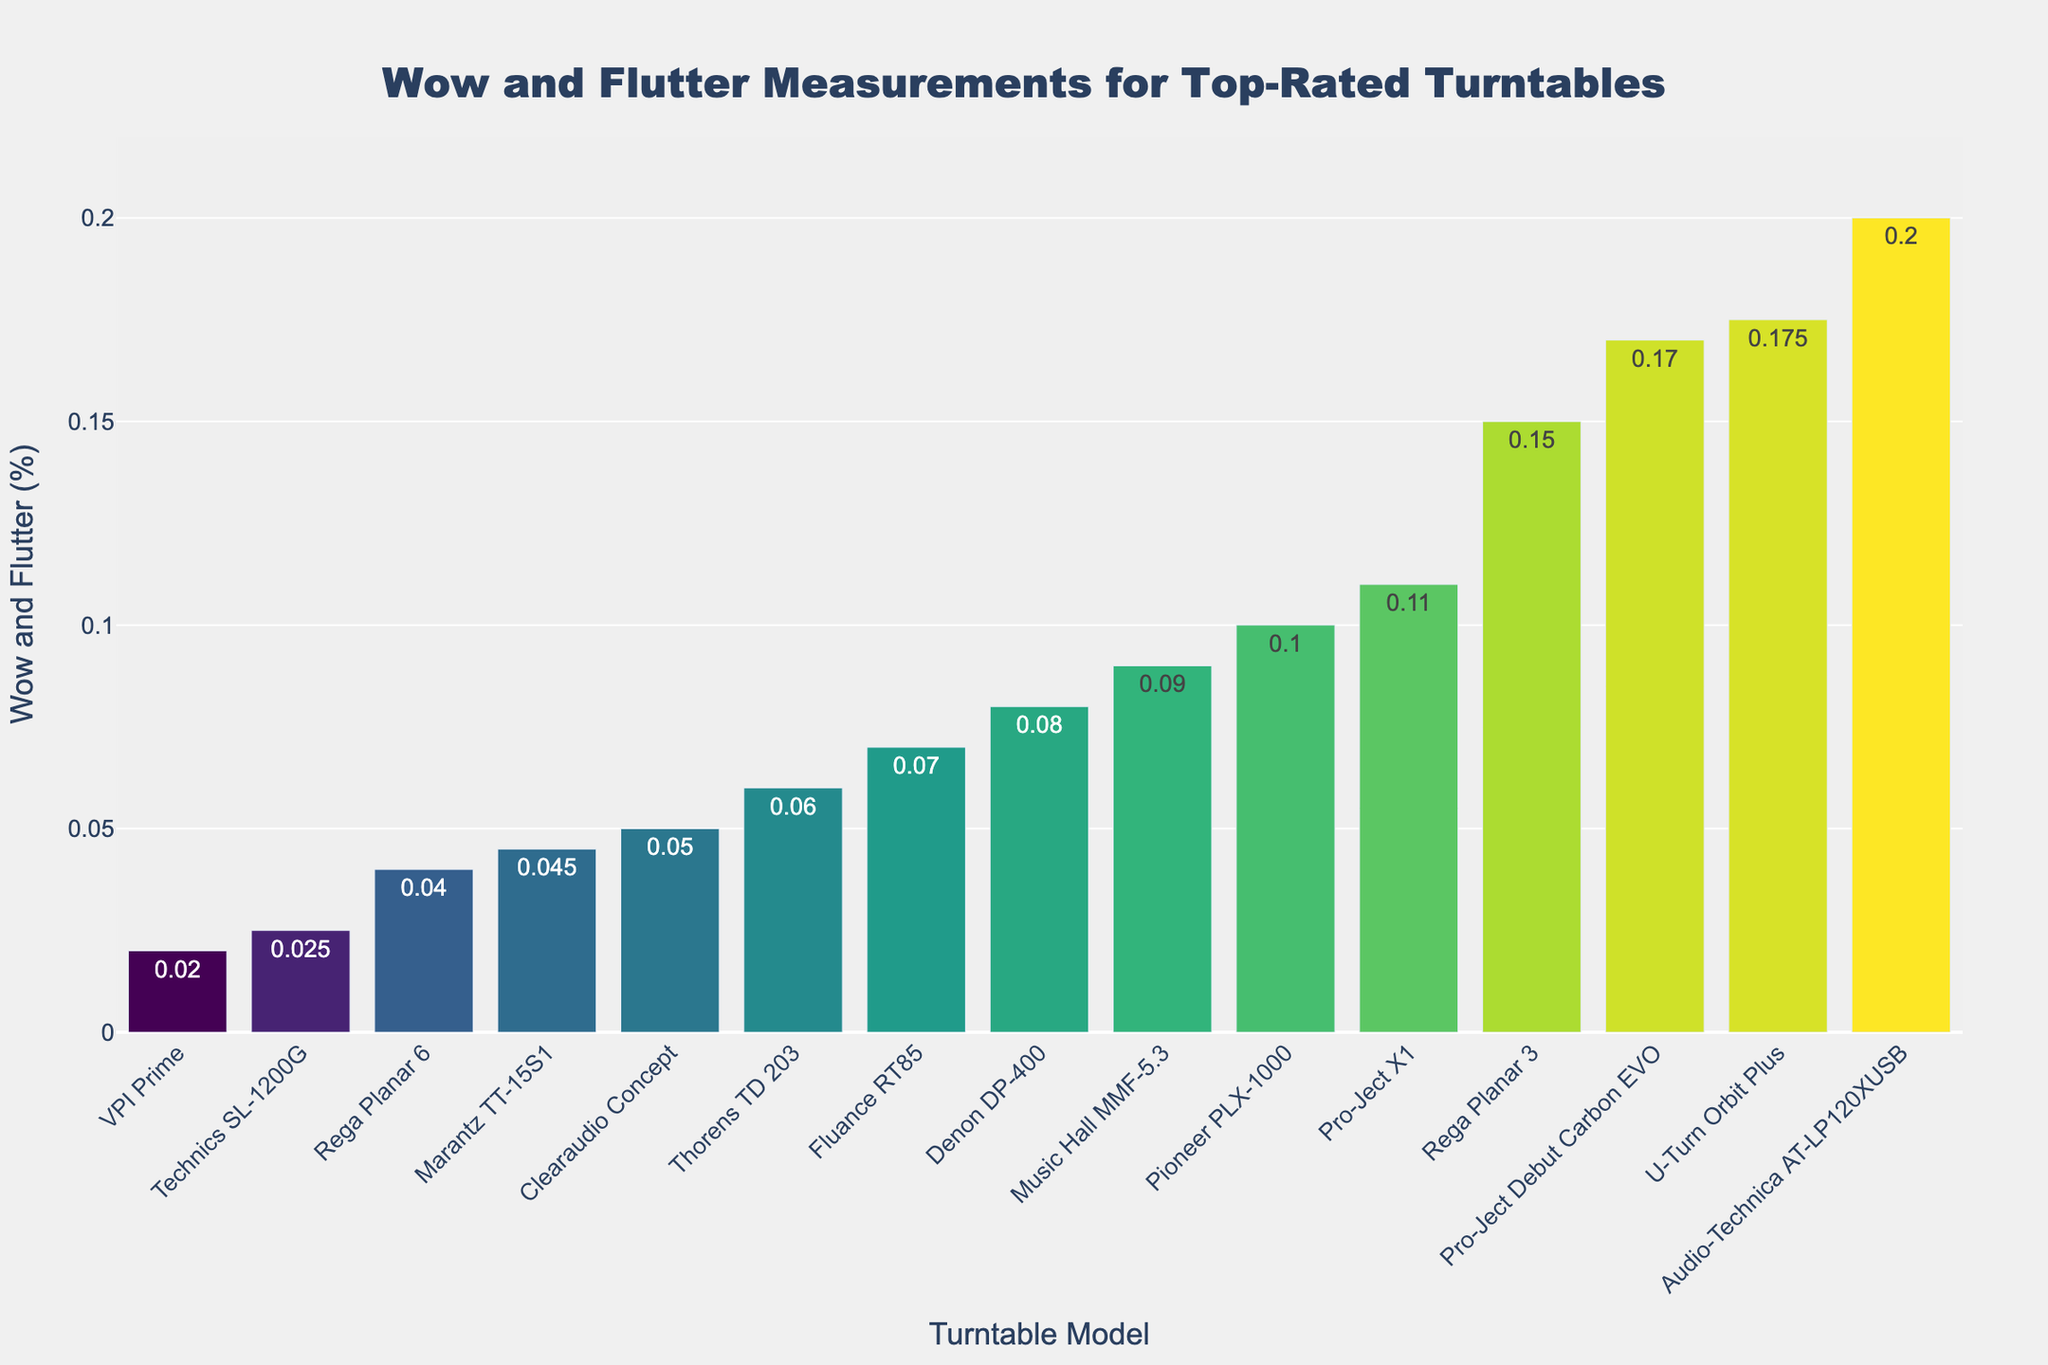What is the wow and flutter percentage for the turntable with the lowest value? Look at the bar with the shortest height, which indicates the smallest wow and flutter percentage. The model with the lowest percentage is the VPI Prime with 0.02%.
Answer: 0.02% Which turntable model has the highest wow and flutter percentage? The tallest bar represents the highest wow and flutter percentage. The model with the highest percentage is the Audio-Technica AT-LP120XUSB with 0.2%.
Answer: Audio-Technica AT-LP120XUSB Compare the wow and flutter values of the Pro-Ject Debut Carbon EVO and the Rega Planar 3. Which one has a lower percentage? Examine the heights of the bars for Pro-Ject Debut Carbon EVO and Rega Planar 3. The Rega Planar 3's bar is shorter, indicating a lower wow and flutter percentage of 0.15% compared to Pro-Ject Debut Carbon EVO's 0.17%.
Answer: Rega Planar 3 Which turntables in the price range $400-$600 have the same wow and flutter percentage? Identify the bars associated with turntables in the $400-$600 price range: Pro-Ject Debut Carbon EVO, Fluance RT85, and Denon DP-400. Only Pro-Ject Debut Carbon EVO and Denon DP-400 share the same percentage at 0.17%.
Answer: None, but Pro-Ject Debut Carbon EVO and U-Turn Orbit Plus both share the same percentage but different price ranges What is the average wow and flutter percentage for turntables in the $3000-$4000 price range? Identify the turntables in the $3000-$4000 price range: Technics SL-1200G and VPI Prime. Their values are 0.025% and 0.02% respectively. The average is (0.025 + 0.02) / 2 = 0.0225%.
Answer: 0.0225% What is the combined wow and flutter percentage for turntables in the $1500-$2000 price range? Locate the turntables in the $1500-$2000 price range: Clearaudio Concept (0.05%) and Rega Planar 6 (0.04%). Add their values: 0.05 + 0.04 = 0.09%.
Answer: 0.09% Among the models priced between $700-$900, which has the lowest wow and flutter percentage? Examine the bars for turntables in the $700-$900 price range: Thorens TD 203 has the shortest bar with 0.06%, which is lower than the other models in this range.
Answer: Thorens TD 203 Which two turntable models have the closest wow and flutter percentages? Look for bars with similar heights. The Pro-Ject Debut Carbon EVO (0.17%) and U-Turn Orbit Plus (0.175%) have the closest wow and flutter percentages.
Answer: Pro-Ject Debut Carbon EVO and U-Turn Orbit Plus How many models have a wow and flutter percentage less than 0.05%? Count the number of bars with heights representing values below 0.05%. The models are Technics SL-1200G, VPI Prime, Marantz TT-15S1, and Rega Planar 6, totaling 4.
Answer: 4 What is the range of wow and flutter percentages for turntables in the $800-$1000 price range? Identify the bars for turntables in the $800-$1000 price range: Rega Planar 3 (0.15%), Music Hall MMF-5.3 (0.09%), and Pro-Ject X1 (0.11%). The range is the difference between the highest and lowest values: 0.15 - 0.09 = 0.06%.
Answer: 0.06% 